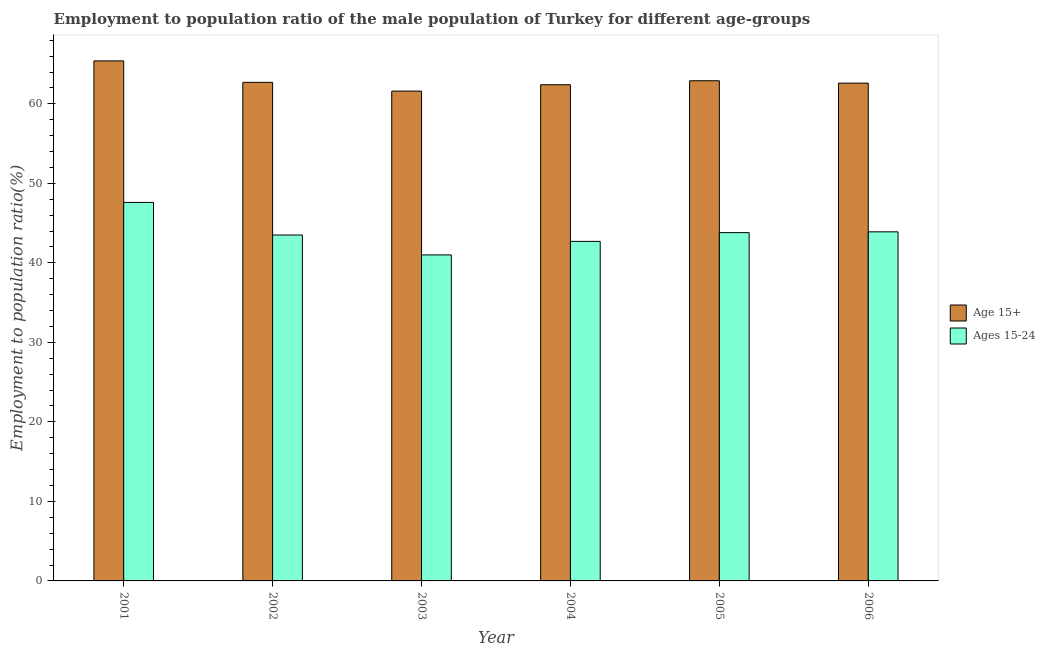Are the number of bars on each tick of the X-axis equal?
Make the answer very short. Yes. How many bars are there on the 3rd tick from the left?
Offer a very short reply. 2. What is the employment to population ratio(age 15+) in 2003?
Ensure brevity in your answer.  61.6. Across all years, what is the maximum employment to population ratio(age 15-24)?
Offer a terse response. 47.6. Across all years, what is the minimum employment to population ratio(age 15+)?
Make the answer very short. 61.6. In which year was the employment to population ratio(age 15-24) maximum?
Offer a very short reply. 2001. What is the total employment to population ratio(age 15+) in the graph?
Your response must be concise. 377.6. What is the difference between the employment to population ratio(age 15+) in 2001 and that in 2006?
Provide a succinct answer. 2.8. What is the difference between the employment to population ratio(age 15-24) in 2005 and the employment to population ratio(age 15+) in 2003?
Your answer should be very brief. 2.8. What is the average employment to population ratio(age 15-24) per year?
Give a very brief answer. 43.75. What is the ratio of the employment to population ratio(age 15+) in 2002 to that in 2003?
Make the answer very short. 1.02. Is the difference between the employment to population ratio(age 15+) in 2001 and 2006 greater than the difference between the employment to population ratio(age 15-24) in 2001 and 2006?
Your answer should be very brief. No. What is the difference between the highest and the second highest employment to population ratio(age 15-24)?
Make the answer very short. 3.7. What is the difference between the highest and the lowest employment to population ratio(age 15+)?
Provide a succinct answer. 3.8. In how many years, is the employment to population ratio(age 15+) greater than the average employment to population ratio(age 15+) taken over all years?
Provide a short and direct response. 1. What does the 1st bar from the left in 2002 represents?
Give a very brief answer. Age 15+. What does the 2nd bar from the right in 2003 represents?
Give a very brief answer. Age 15+. How many bars are there?
Provide a short and direct response. 12. How many years are there in the graph?
Make the answer very short. 6. What is the difference between two consecutive major ticks on the Y-axis?
Offer a very short reply. 10. Are the values on the major ticks of Y-axis written in scientific E-notation?
Ensure brevity in your answer.  No. Does the graph contain any zero values?
Ensure brevity in your answer.  No. Does the graph contain grids?
Provide a succinct answer. No. Where does the legend appear in the graph?
Make the answer very short. Center right. What is the title of the graph?
Your response must be concise. Employment to population ratio of the male population of Turkey for different age-groups. What is the Employment to population ratio(%) in Age 15+ in 2001?
Keep it short and to the point. 65.4. What is the Employment to population ratio(%) of Ages 15-24 in 2001?
Provide a succinct answer. 47.6. What is the Employment to population ratio(%) in Age 15+ in 2002?
Keep it short and to the point. 62.7. What is the Employment to population ratio(%) in Ages 15-24 in 2002?
Keep it short and to the point. 43.5. What is the Employment to population ratio(%) of Age 15+ in 2003?
Ensure brevity in your answer.  61.6. What is the Employment to population ratio(%) in Age 15+ in 2004?
Your answer should be compact. 62.4. What is the Employment to population ratio(%) of Ages 15-24 in 2004?
Your answer should be very brief. 42.7. What is the Employment to population ratio(%) in Age 15+ in 2005?
Your answer should be very brief. 62.9. What is the Employment to population ratio(%) of Ages 15-24 in 2005?
Keep it short and to the point. 43.8. What is the Employment to population ratio(%) in Age 15+ in 2006?
Your answer should be very brief. 62.6. What is the Employment to population ratio(%) of Ages 15-24 in 2006?
Provide a short and direct response. 43.9. Across all years, what is the maximum Employment to population ratio(%) in Age 15+?
Your answer should be very brief. 65.4. Across all years, what is the maximum Employment to population ratio(%) in Ages 15-24?
Give a very brief answer. 47.6. Across all years, what is the minimum Employment to population ratio(%) in Age 15+?
Offer a very short reply. 61.6. What is the total Employment to population ratio(%) in Age 15+ in the graph?
Give a very brief answer. 377.6. What is the total Employment to population ratio(%) in Ages 15-24 in the graph?
Offer a terse response. 262.5. What is the difference between the Employment to population ratio(%) of Ages 15-24 in 2001 and that in 2002?
Provide a succinct answer. 4.1. What is the difference between the Employment to population ratio(%) of Age 15+ in 2001 and that in 2003?
Provide a short and direct response. 3.8. What is the difference between the Employment to population ratio(%) in Ages 15-24 in 2001 and that in 2004?
Your response must be concise. 4.9. What is the difference between the Employment to population ratio(%) in Ages 15-24 in 2002 and that in 2003?
Give a very brief answer. 2.5. What is the difference between the Employment to population ratio(%) in Age 15+ in 2002 and that in 2005?
Your response must be concise. -0.2. What is the difference between the Employment to population ratio(%) of Age 15+ in 2003 and that in 2004?
Give a very brief answer. -0.8. What is the difference between the Employment to population ratio(%) in Ages 15-24 in 2003 and that in 2004?
Make the answer very short. -1.7. What is the difference between the Employment to population ratio(%) in Age 15+ in 2003 and that in 2005?
Make the answer very short. -1.3. What is the difference between the Employment to population ratio(%) of Ages 15-24 in 2003 and that in 2005?
Make the answer very short. -2.8. What is the difference between the Employment to population ratio(%) in Age 15+ in 2004 and that in 2005?
Provide a short and direct response. -0.5. What is the difference between the Employment to population ratio(%) in Ages 15-24 in 2004 and that in 2005?
Your answer should be very brief. -1.1. What is the difference between the Employment to population ratio(%) of Age 15+ in 2004 and that in 2006?
Your answer should be compact. -0.2. What is the difference between the Employment to population ratio(%) in Ages 15-24 in 2005 and that in 2006?
Provide a succinct answer. -0.1. What is the difference between the Employment to population ratio(%) in Age 15+ in 2001 and the Employment to population ratio(%) in Ages 15-24 in 2002?
Your answer should be compact. 21.9. What is the difference between the Employment to population ratio(%) in Age 15+ in 2001 and the Employment to population ratio(%) in Ages 15-24 in 2003?
Make the answer very short. 24.4. What is the difference between the Employment to population ratio(%) of Age 15+ in 2001 and the Employment to population ratio(%) of Ages 15-24 in 2004?
Offer a terse response. 22.7. What is the difference between the Employment to population ratio(%) in Age 15+ in 2001 and the Employment to population ratio(%) in Ages 15-24 in 2005?
Your response must be concise. 21.6. What is the difference between the Employment to population ratio(%) in Age 15+ in 2001 and the Employment to population ratio(%) in Ages 15-24 in 2006?
Your answer should be compact. 21.5. What is the difference between the Employment to population ratio(%) of Age 15+ in 2002 and the Employment to population ratio(%) of Ages 15-24 in 2003?
Ensure brevity in your answer.  21.7. What is the difference between the Employment to population ratio(%) in Age 15+ in 2002 and the Employment to population ratio(%) in Ages 15-24 in 2004?
Your response must be concise. 20. What is the difference between the Employment to population ratio(%) of Age 15+ in 2003 and the Employment to population ratio(%) of Ages 15-24 in 2004?
Ensure brevity in your answer.  18.9. What is the difference between the Employment to population ratio(%) in Age 15+ in 2003 and the Employment to population ratio(%) in Ages 15-24 in 2005?
Your response must be concise. 17.8. What is the difference between the Employment to population ratio(%) of Age 15+ in 2003 and the Employment to population ratio(%) of Ages 15-24 in 2006?
Your answer should be very brief. 17.7. What is the difference between the Employment to population ratio(%) of Age 15+ in 2004 and the Employment to population ratio(%) of Ages 15-24 in 2005?
Provide a short and direct response. 18.6. What is the difference between the Employment to population ratio(%) of Age 15+ in 2004 and the Employment to population ratio(%) of Ages 15-24 in 2006?
Offer a terse response. 18.5. What is the average Employment to population ratio(%) of Age 15+ per year?
Your response must be concise. 62.93. What is the average Employment to population ratio(%) of Ages 15-24 per year?
Offer a terse response. 43.75. In the year 2002, what is the difference between the Employment to population ratio(%) of Age 15+ and Employment to population ratio(%) of Ages 15-24?
Your response must be concise. 19.2. In the year 2003, what is the difference between the Employment to population ratio(%) in Age 15+ and Employment to population ratio(%) in Ages 15-24?
Ensure brevity in your answer.  20.6. What is the ratio of the Employment to population ratio(%) in Age 15+ in 2001 to that in 2002?
Offer a very short reply. 1.04. What is the ratio of the Employment to population ratio(%) of Ages 15-24 in 2001 to that in 2002?
Provide a succinct answer. 1.09. What is the ratio of the Employment to population ratio(%) in Age 15+ in 2001 to that in 2003?
Offer a very short reply. 1.06. What is the ratio of the Employment to population ratio(%) in Ages 15-24 in 2001 to that in 2003?
Make the answer very short. 1.16. What is the ratio of the Employment to population ratio(%) in Age 15+ in 2001 to that in 2004?
Your response must be concise. 1.05. What is the ratio of the Employment to population ratio(%) in Ages 15-24 in 2001 to that in 2004?
Offer a very short reply. 1.11. What is the ratio of the Employment to population ratio(%) of Age 15+ in 2001 to that in 2005?
Your answer should be compact. 1.04. What is the ratio of the Employment to population ratio(%) in Ages 15-24 in 2001 to that in 2005?
Your answer should be very brief. 1.09. What is the ratio of the Employment to population ratio(%) of Age 15+ in 2001 to that in 2006?
Keep it short and to the point. 1.04. What is the ratio of the Employment to population ratio(%) of Ages 15-24 in 2001 to that in 2006?
Your answer should be compact. 1.08. What is the ratio of the Employment to population ratio(%) in Age 15+ in 2002 to that in 2003?
Your answer should be compact. 1.02. What is the ratio of the Employment to population ratio(%) of Ages 15-24 in 2002 to that in 2003?
Your answer should be compact. 1.06. What is the ratio of the Employment to population ratio(%) of Age 15+ in 2002 to that in 2004?
Keep it short and to the point. 1. What is the ratio of the Employment to population ratio(%) in Ages 15-24 in 2002 to that in 2004?
Offer a terse response. 1.02. What is the ratio of the Employment to population ratio(%) of Ages 15-24 in 2002 to that in 2005?
Offer a very short reply. 0.99. What is the ratio of the Employment to population ratio(%) of Ages 15-24 in 2002 to that in 2006?
Your response must be concise. 0.99. What is the ratio of the Employment to population ratio(%) in Age 15+ in 2003 to that in 2004?
Ensure brevity in your answer.  0.99. What is the ratio of the Employment to population ratio(%) of Ages 15-24 in 2003 to that in 2004?
Your answer should be compact. 0.96. What is the ratio of the Employment to population ratio(%) in Age 15+ in 2003 to that in 2005?
Provide a succinct answer. 0.98. What is the ratio of the Employment to population ratio(%) in Ages 15-24 in 2003 to that in 2005?
Provide a short and direct response. 0.94. What is the ratio of the Employment to population ratio(%) in Ages 15-24 in 2003 to that in 2006?
Give a very brief answer. 0.93. What is the ratio of the Employment to population ratio(%) of Ages 15-24 in 2004 to that in 2005?
Keep it short and to the point. 0.97. What is the ratio of the Employment to population ratio(%) of Ages 15-24 in 2004 to that in 2006?
Make the answer very short. 0.97. What is the ratio of the Employment to population ratio(%) in Ages 15-24 in 2005 to that in 2006?
Offer a terse response. 1. What is the difference between the highest and the second highest Employment to population ratio(%) of Age 15+?
Offer a very short reply. 2.5. What is the difference between the highest and the second highest Employment to population ratio(%) of Ages 15-24?
Your answer should be compact. 3.7. 